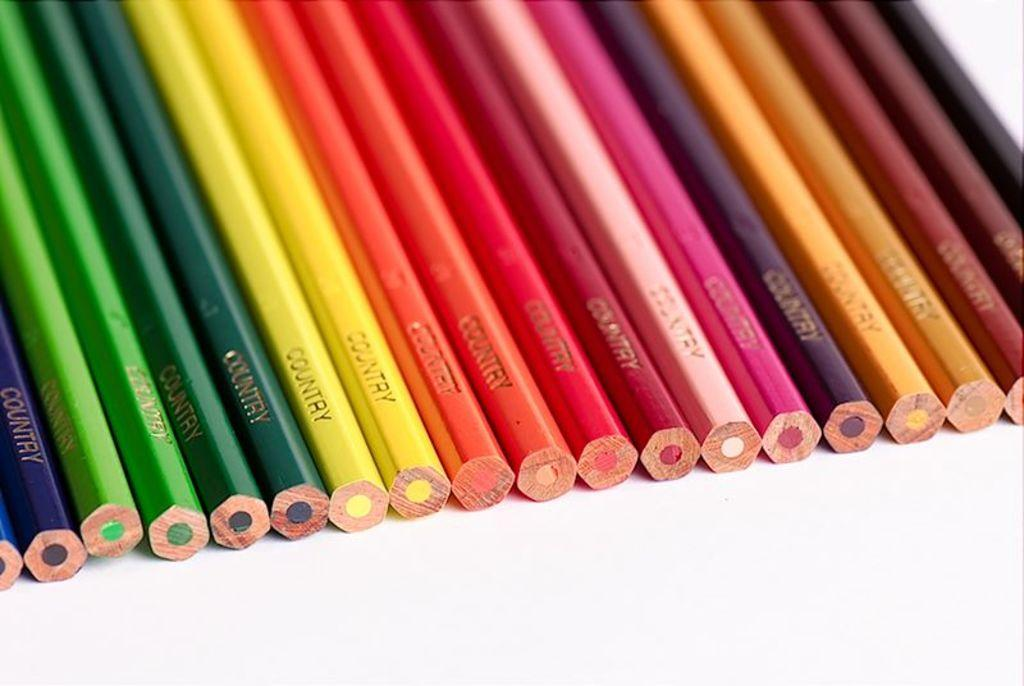<image>
Write a terse but informative summary of the picture. Many rainbow colored color pencils with the word "Country" on them. 